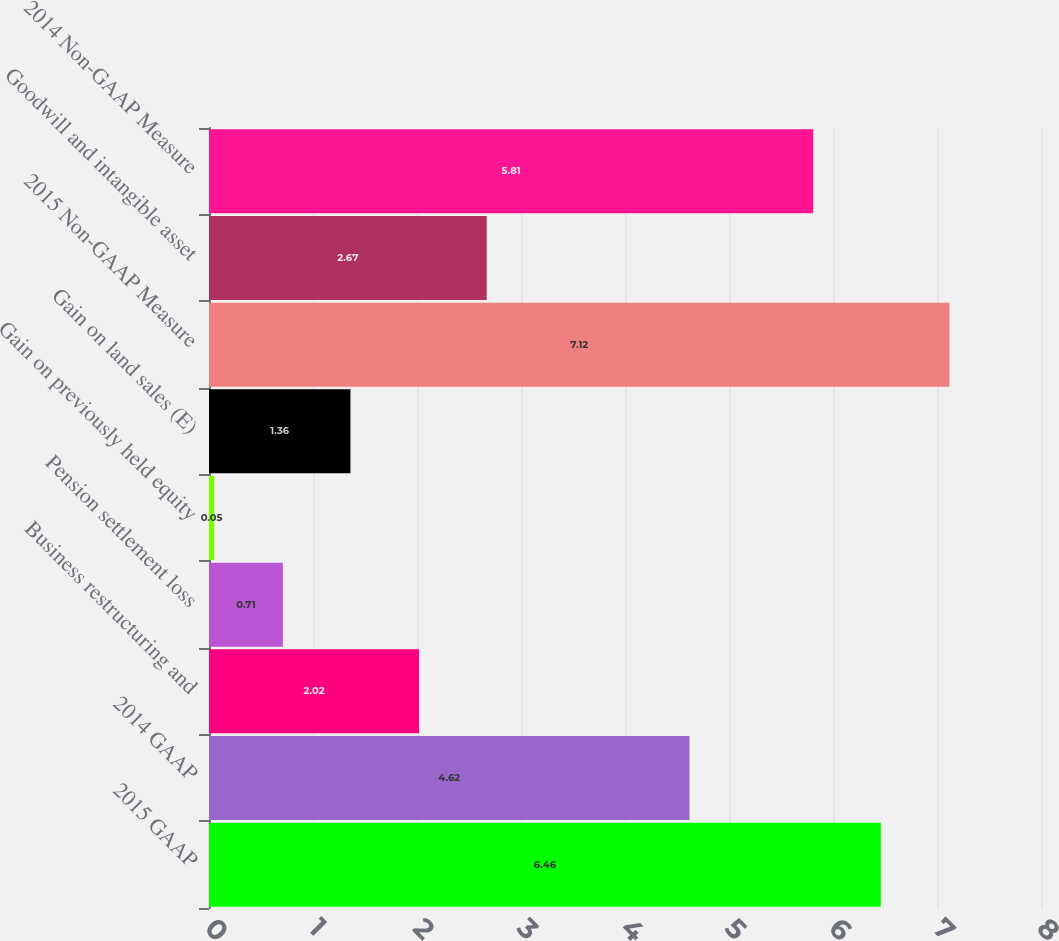Convert chart. <chart><loc_0><loc_0><loc_500><loc_500><bar_chart><fcel>2015 GAAP<fcel>2014 GAAP<fcel>Business restructuring and<fcel>Pension settlement loss<fcel>Gain on previously held equity<fcel>Gain on land sales (E)<fcel>2015 Non-GAAP Measure<fcel>Goodwill and intangible asset<fcel>2014 Non-GAAP Measure<nl><fcel>6.46<fcel>4.62<fcel>2.02<fcel>0.71<fcel>0.05<fcel>1.36<fcel>7.12<fcel>2.67<fcel>5.81<nl></chart> 